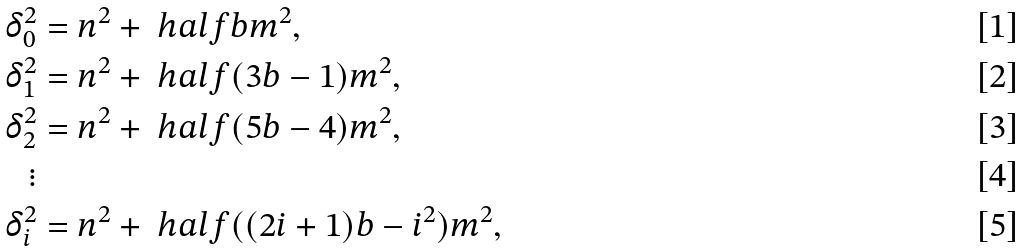<formula> <loc_0><loc_0><loc_500><loc_500>\delta _ { 0 } ^ { 2 } & = n ^ { 2 } + \ h a l f b m ^ { 2 } , \\ \delta _ { 1 } ^ { 2 } & = n ^ { 2 } + \ h a l f ( 3 b - 1 ) m ^ { 2 } , \\ \delta _ { 2 } ^ { 2 } & = n ^ { 2 } + \ h a l f ( 5 b - 4 ) m ^ { 2 } , \\ \vdots \\ \delta _ { i } ^ { 2 } & = n ^ { 2 } + \ h a l f ( ( 2 i + 1 ) b - i ^ { 2 } ) m ^ { 2 } ,</formula> 